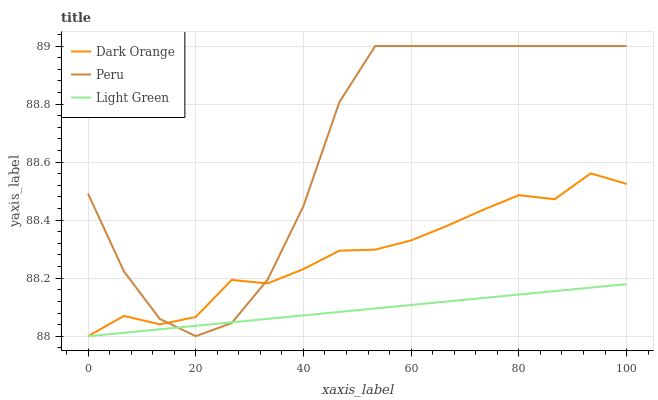Does Light Green have the minimum area under the curve?
Answer yes or no. Yes. Does Peru have the maximum area under the curve?
Answer yes or no. Yes. Does Peru have the minimum area under the curve?
Answer yes or no. No. Does Light Green have the maximum area under the curve?
Answer yes or no. No. Is Light Green the smoothest?
Answer yes or no. Yes. Is Peru the roughest?
Answer yes or no. Yes. Is Peru the smoothest?
Answer yes or no. No. Is Light Green the roughest?
Answer yes or no. No. Does Dark Orange have the lowest value?
Answer yes or no. Yes. Does Peru have the lowest value?
Answer yes or no. No. Does Peru have the highest value?
Answer yes or no. Yes. Does Light Green have the highest value?
Answer yes or no. No. Does Dark Orange intersect Peru?
Answer yes or no. Yes. Is Dark Orange less than Peru?
Answer yes or no. No. Is Dark Orange greater than Peru?
Answer yes or no. No. 